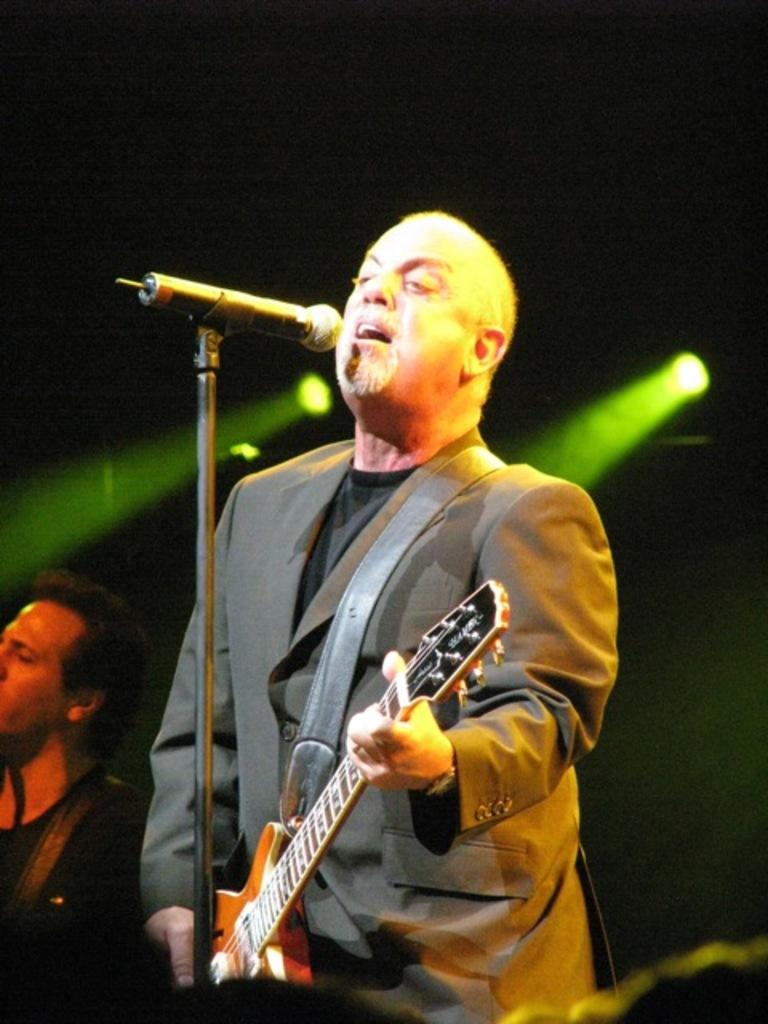What is the man in the image doing? The man in the image is singing. What is the man holding while singing? The man is holding a microphone. What musical instrument is the man playing? The man is playing a guitar. Is there anyone else present in the image? Yes, there is another man beside the singing man. What type of plants can be seen growing in the jail where the man is singing? There is no jail present in the image, nor are there any plants visible. 